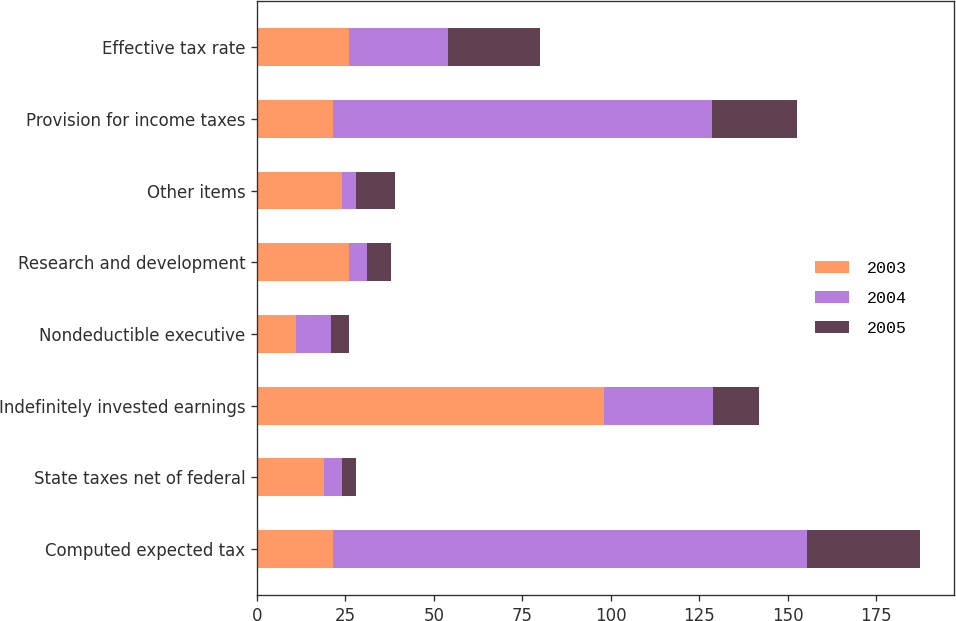Convert chart to OTSL. <chart><loc_0><loc_0><loc_500><loc_500><stacked_bar_chart><ecel><fcel>Computed expected tax<fcel>State taxes net of federal<fcel>Indefinitely invested earnings<fcel>Nondeductible executive<fcel>Research and development<fcel>Other items<fcel>Provision for income taxes<fcel>Effective tax rate<nl><fcel>2003<fcel>21.5<fcel>19<fcel>98<fcel>11<fcel>26<fcel>24<fcel>21.5<fcel>26<nl><fcel>2004<fcel>134<fcel>5<fcel>31<fcel>10<fcel>5<fcel>4<fcel>107<fcel>28<nl><fcel>2005<fcel>32<fcel>4<fcel>13<fcel>5<fcel>7<fcel>11<fcel>24<fcel>26<nl></chart> 